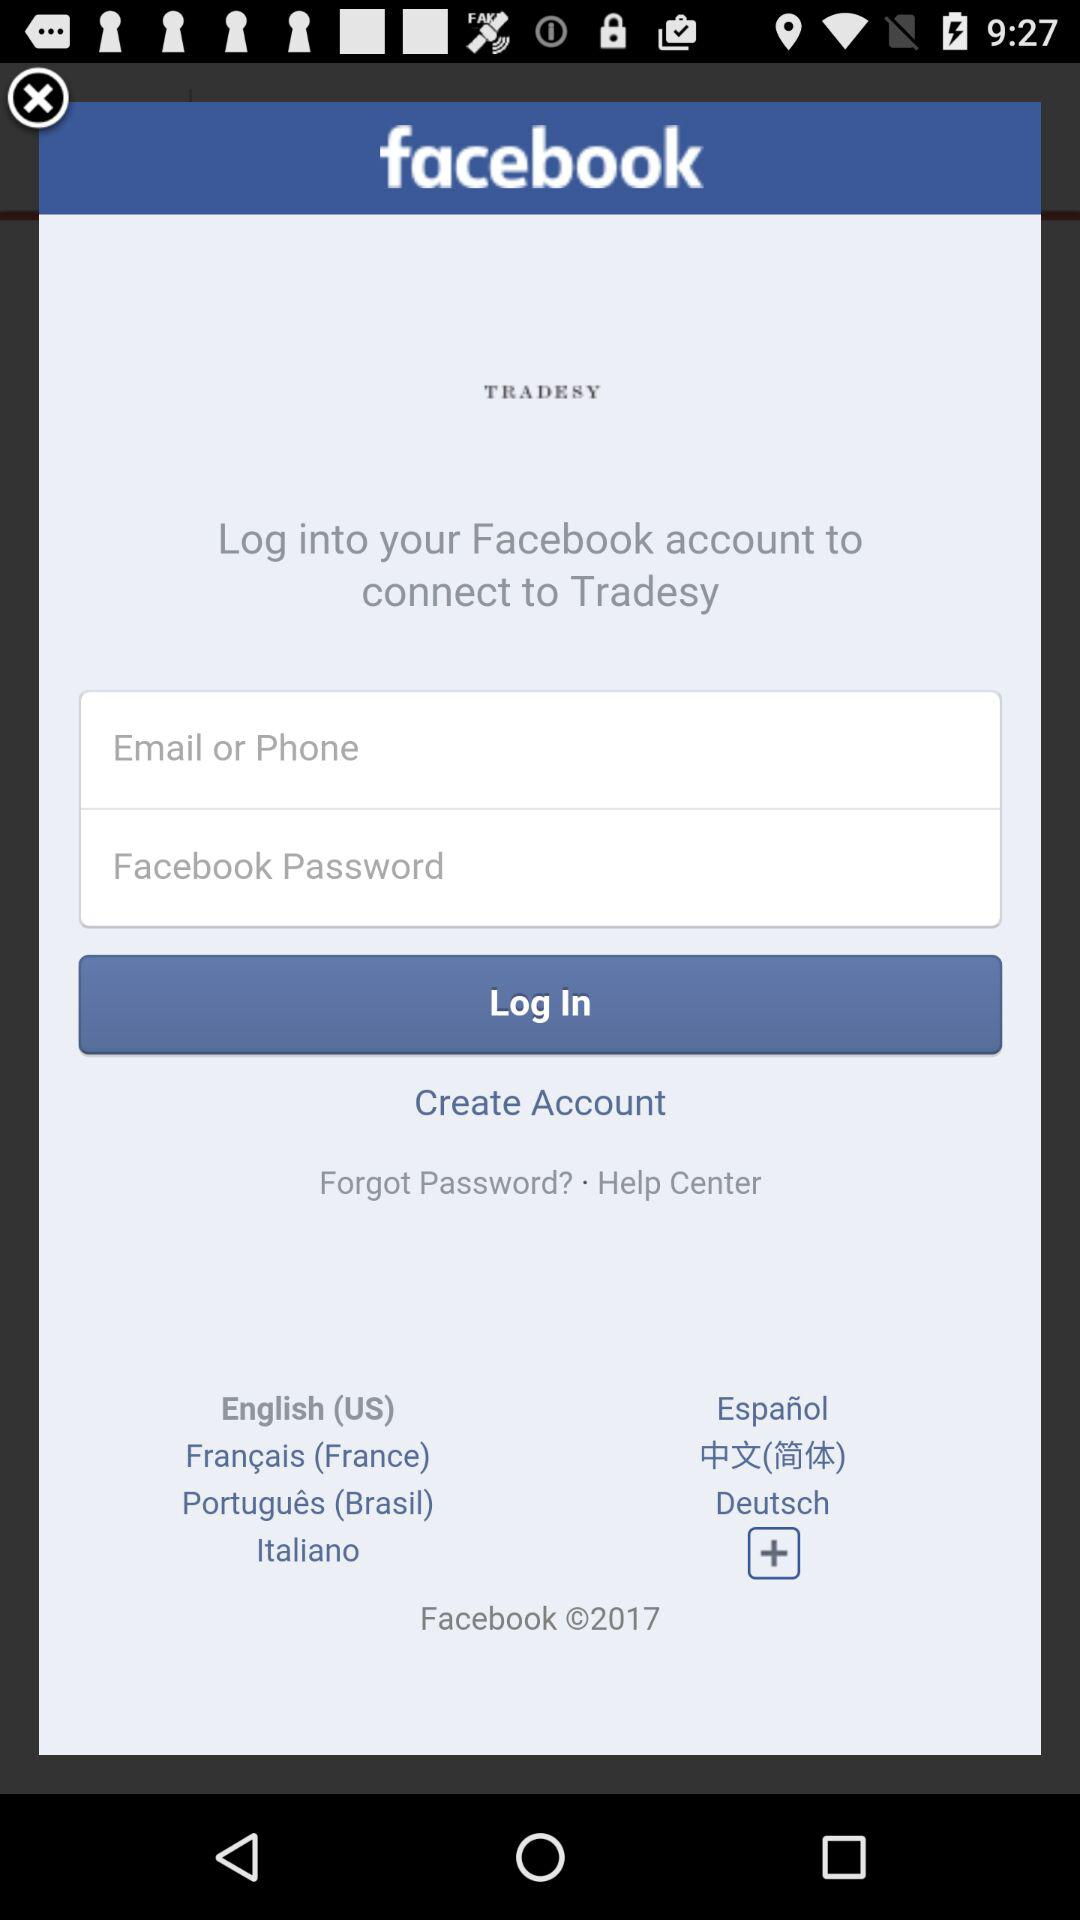How many text inputs are on this page?
Answer the question using a single word or phrase. 2 